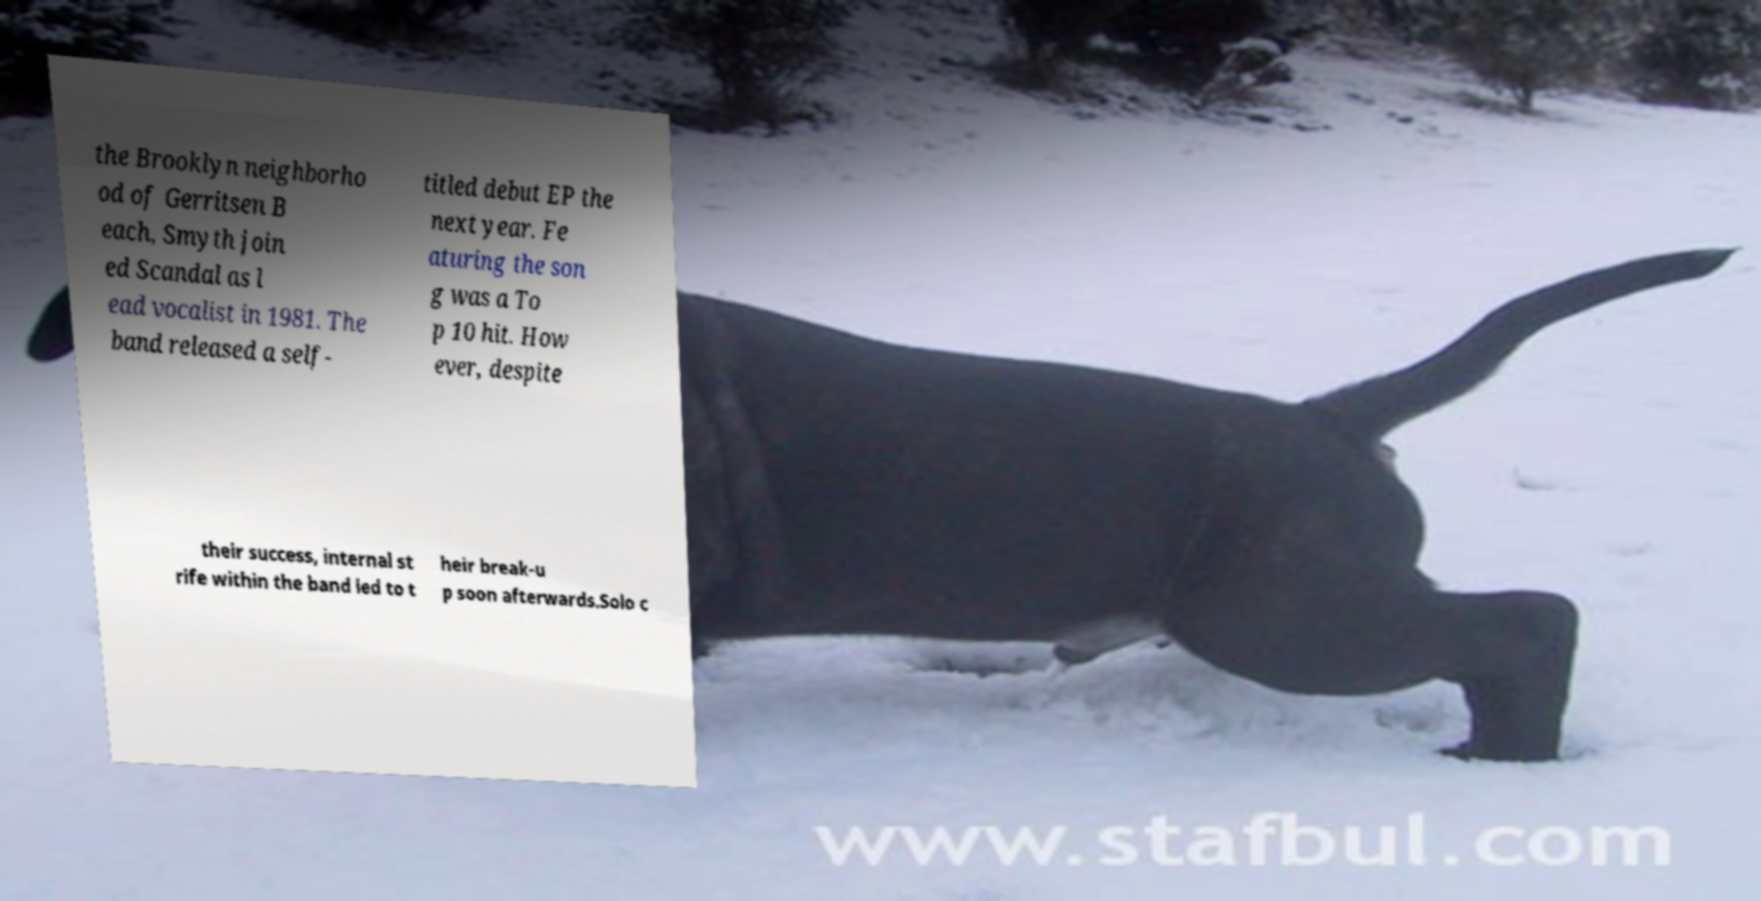Please read and relay the text visible in this image. What does it say? the Brooklyn neighborho od of Gerritsen B each, Smyth join ed Scandal as l ead vocalist in 1981. The band released a self- titled debut EP the next year. Fe aturing the son g was a To p 10 hit. How ever, despite their success, internal st rife within the band led to t heir break-u p soon afterwards.Solo c 